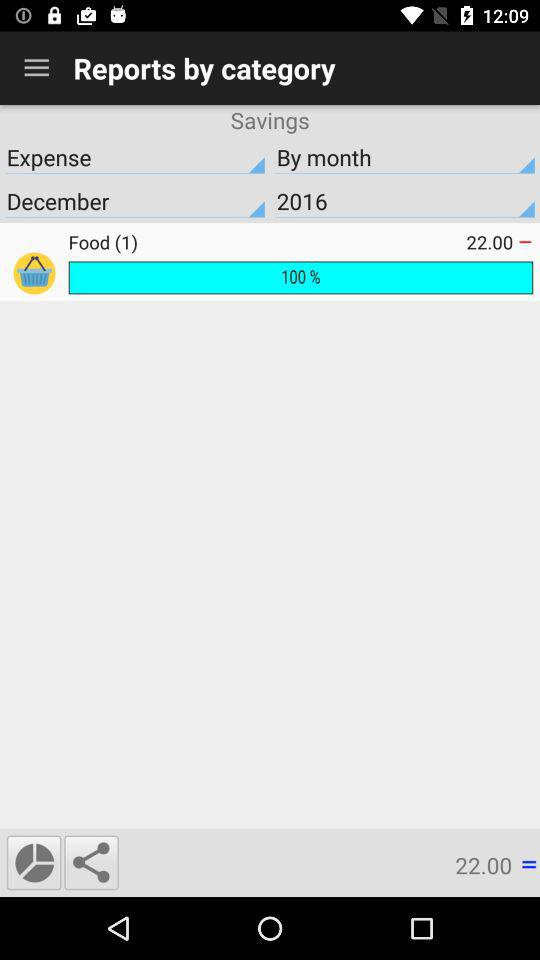What percentage of the "Food (1)" amount has been spent? The percentage of the "Food (1)" amount that has been spent is 100. 